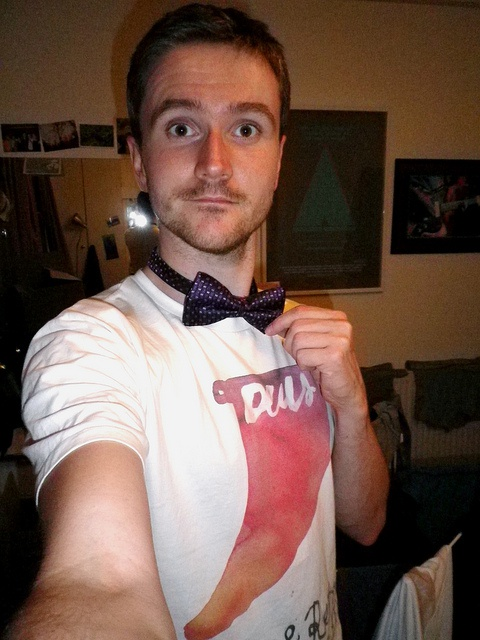Describe the objects in this image and their specific colors. I can see people in black, lightgray, brown, and lightpink tones and tie in black, purple, and navy tones in this image. 